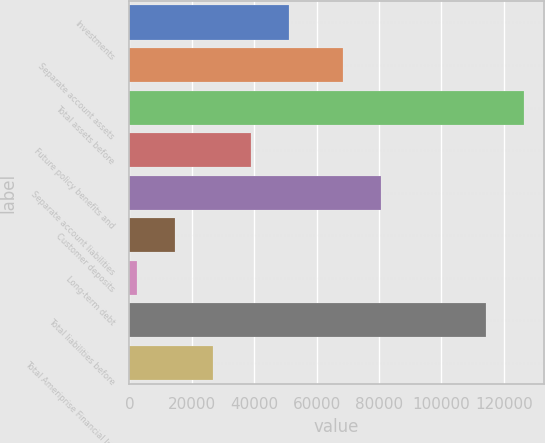<chart> <loc_0><loc_0><loc_500><loc_500><bar_chart><fcel>Investments<fcel>Separate account assets<fcel>Total assets before<fcel>Future policy benefits and<fcel>Separate account liabilities<fcel>Customer deposits<fcel>Long-term debt<fcel>Total liabilities before<fcel>Total Ameriprise Financial Inc<nl><fcel>51118.6<fcel>68330<fcel>126383<fcel>38918.2<fcel>80530.4<fcel>14517.4<fcel>2317<fcel>114183<fcel>26717.8<nl></chart> 